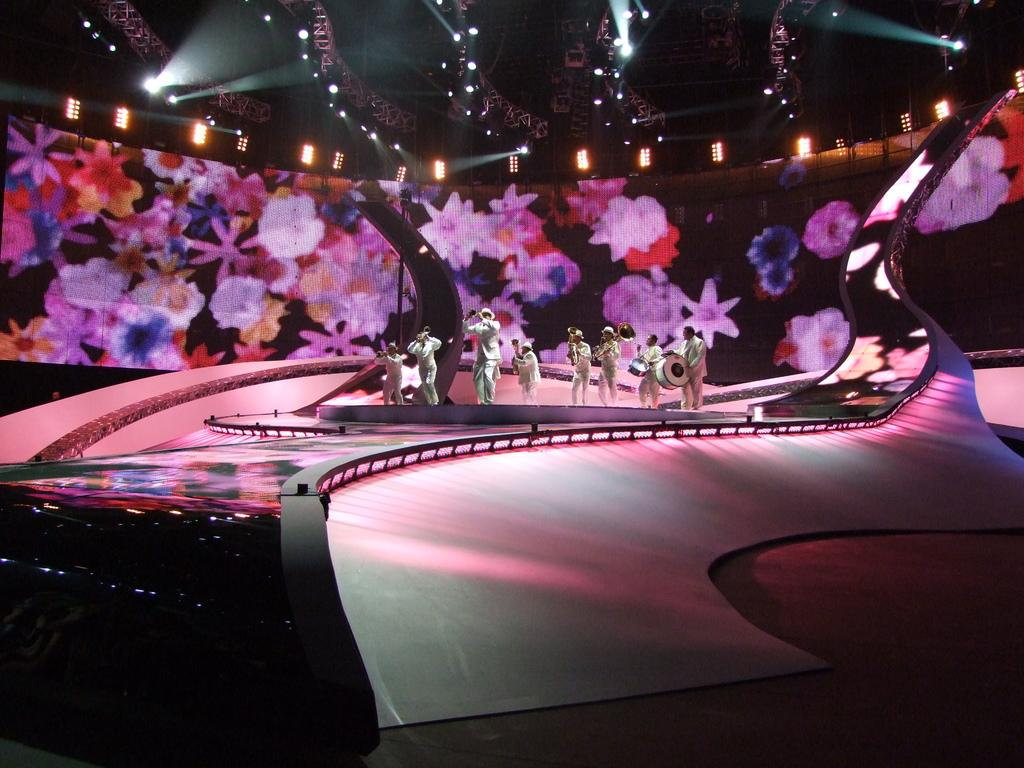What is the main subject of the image? The main subject of the image is a group of people. What are the people in the image doing? The people are standing, and two of them are playing musical drums. What are the people wearing in the image? The people in the image are wearing clothes. What can be seen at the top of the image? There are lights at the top of the image. Can you see a canvas in the image? There is no canvas present in the image. Are the people in the image kissing each other? The provided facts do not mention any kissing between the people in the image. 